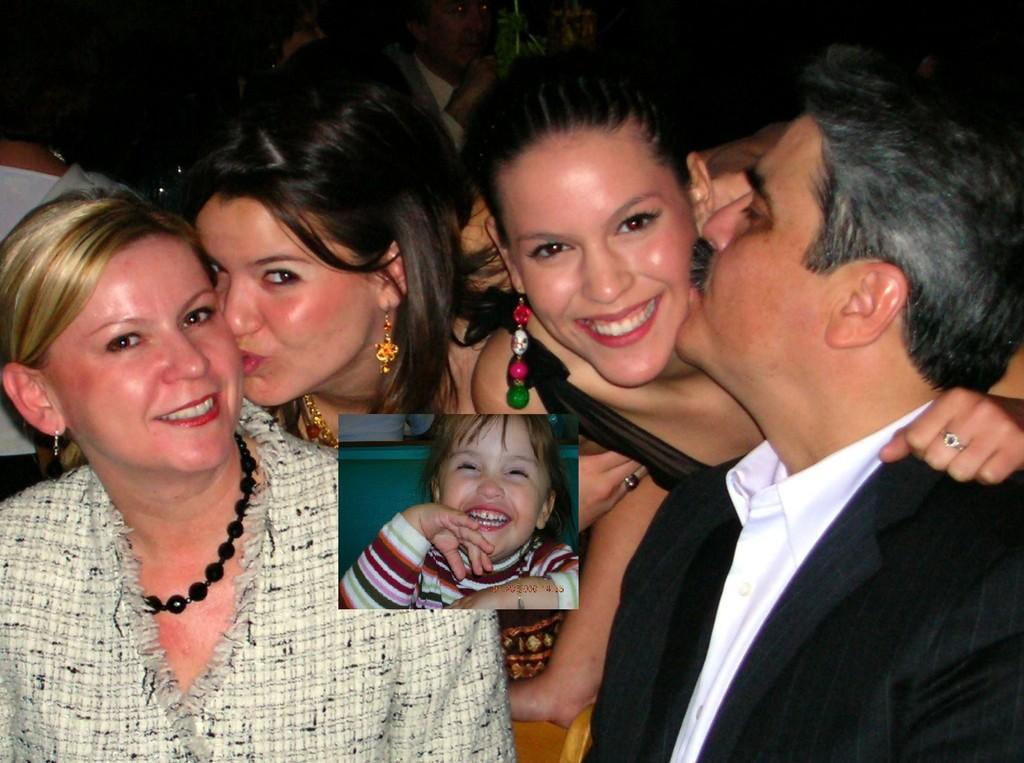Please provide a concise description of this image. In the center of the image we can see a few people are smiling, which we can see on their faces. And we can see two persons are kissing opposite persons. In the middle of the image, we can see one baby is smiling. In the background we can see a few people and a few other objects. 